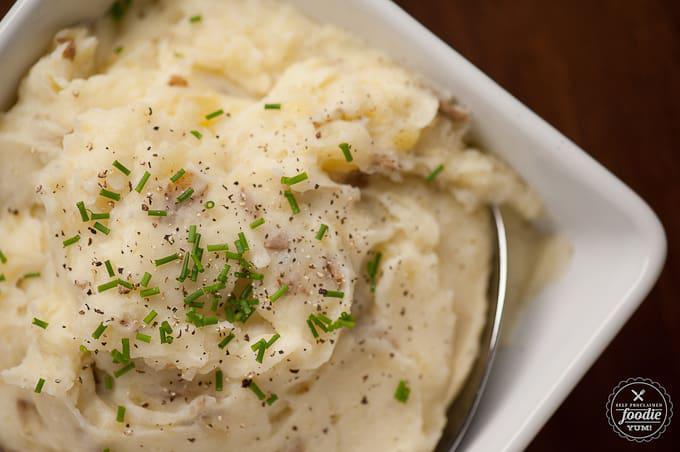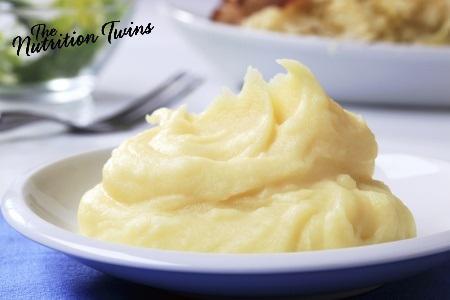The first image is the image on the left, the second image is the image on the right. Given the left and right images, does the statement "A fork sits near a plate of food in one of the images." hold true? Answer yes or no. Yes. 